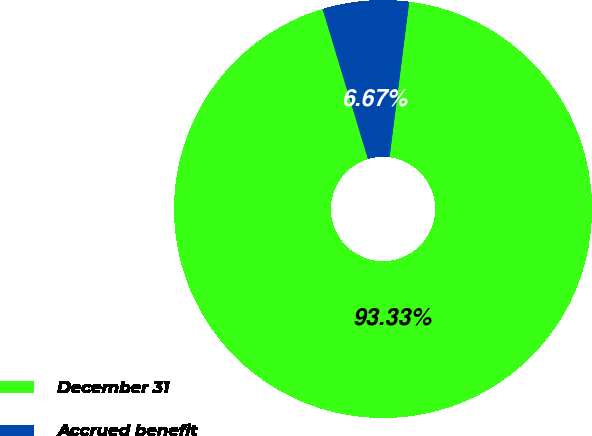Convert chart. <chart><loc_0><loc_0><loc_500><loc_500><pie_chart><fcel>December 31<fcel>Accrued benefit<nl><fcel>93.33%<fcel>6.67%<nl></chart> 